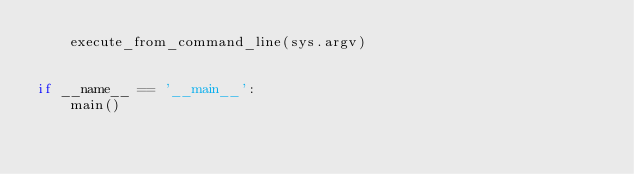Convert code to text. <code><loc_0><loc_0><loc_500><loc_500><_Python_>    execute_from_command_line(sys.argv)


if __name__ == '__main__':
    main()
</code> 